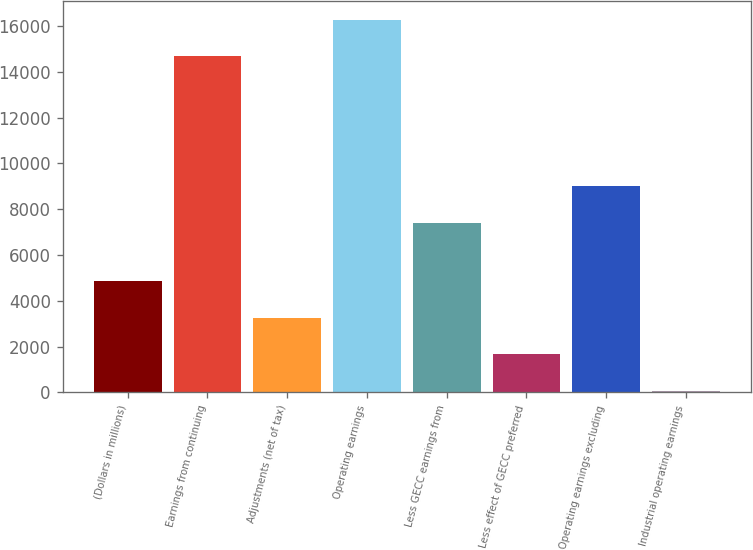Convert chart. <chart><loc_0><loc_0><loc_500><loc_500><bar_chart><fcel>(Dollars in millions)<fcel>Earnings from continuing<fcel>Adjustments (net of tax)<fcel>Operating earnings<fcel>Less GECC earnings from<fcel>Less effect of GECC preferred<fcel>Operating earnings excluding<fcel>Industrial operating earnings<nl><fcel>4858<fcel>14679<fcel>3257<fcel>16280<fcel>7401<fcel>1656<fcel>9002<fcel>55<nl></chart> 